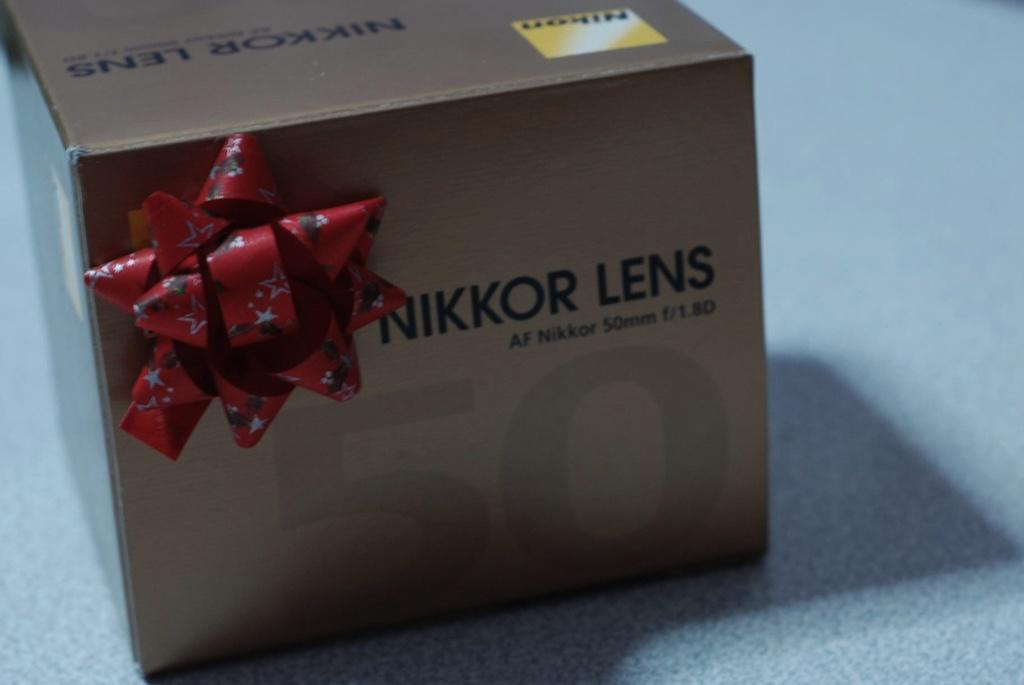<image>
Describe the image concisely. A cardboard box from Nikkor Lens with a bow 